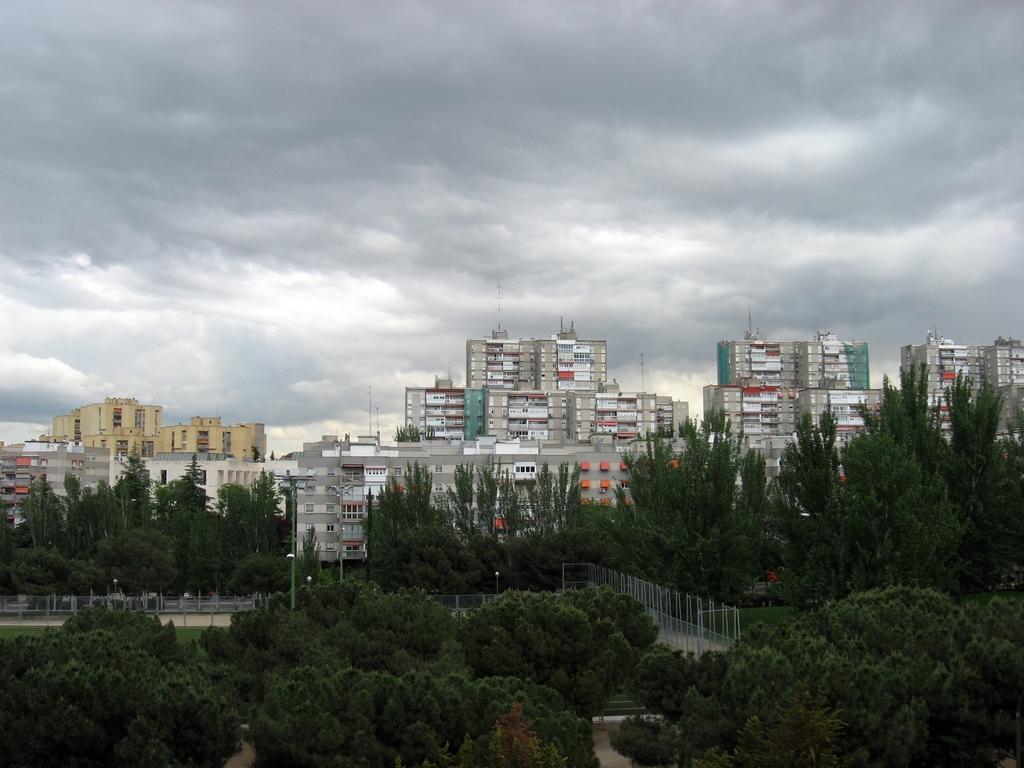Describe this image in one or two sentences. In this picture we can see trees, fences, poles, buildings with windows and in the background we can see the sky with clouds. 